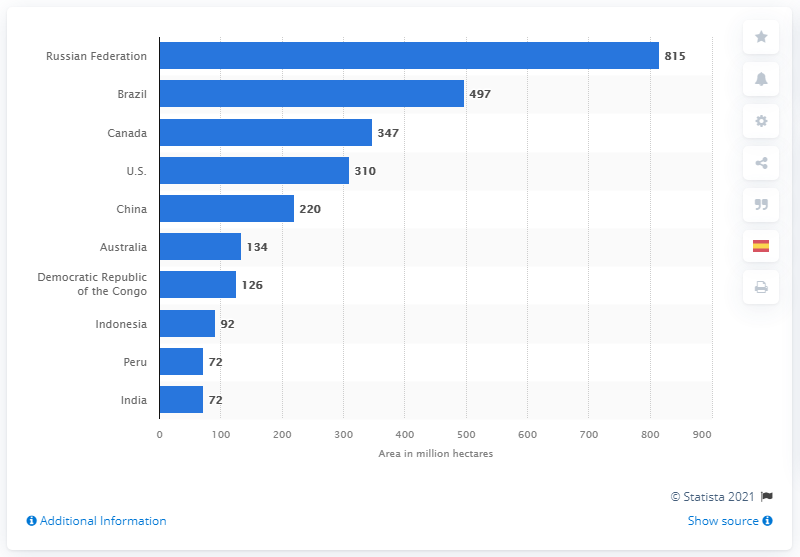Specify some key components in this picture. In 2020, Brazil had a total forest area of 497 million hectares. 